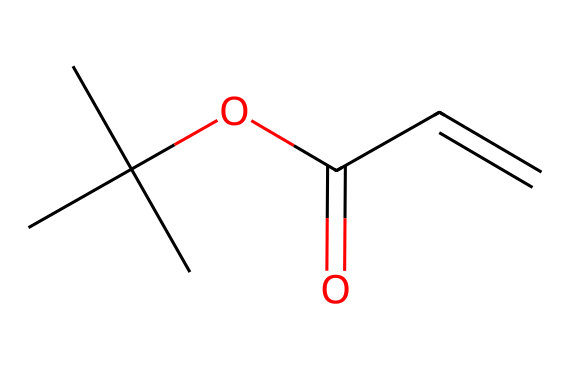What is the main functional group in this chemical? The structure contains an ester functional group indicated by the presence of the carbonyl (C=O) and an alkoxy group (CC(C)(C)O-). This points to it being an ester.
Answer: ester How many carbon atoms are in this chemical? Counting the carbon atoms in the SMILES representation, there are 6 carbon atoms present in the structure.
Answer: 6 What type of compound is this based on its usage in photoresists? Given that this chemical is used in photoresists for microfabrication processes, it can be categorized as a polymeric compound due to its structural arrangement often related to photopolymerizable materials.
Answer: polymer What is the significance of the double bond in the structure? The presence of a double bond (C=C) indicates that the compound can undergo polymerization upon exposure to light, essential for the function of photoresists in creating patterns.
Answer: polymerization Which part of the structure contributes to its photo-reactivity? The double bond in the structure is crucial for photo-reactivity because it allows the chemical to change upon exposure to light, leading to cross-linking necessary in photoresist applications.
Answer: double bond How many oxygen atoms are present in this chemical? Looking at the structure, there are 2 oxygen atoms: one in the ester group and one in the alkoxy group.
Answer: 2 What role does the branched alkyl group play in the chemical properties? The branched alkyl group (CC(C)(C)-) influences the solubility and viscosity of the photoresist, affecting the ease of application and the final film properties.
Answer: influences viscosity 